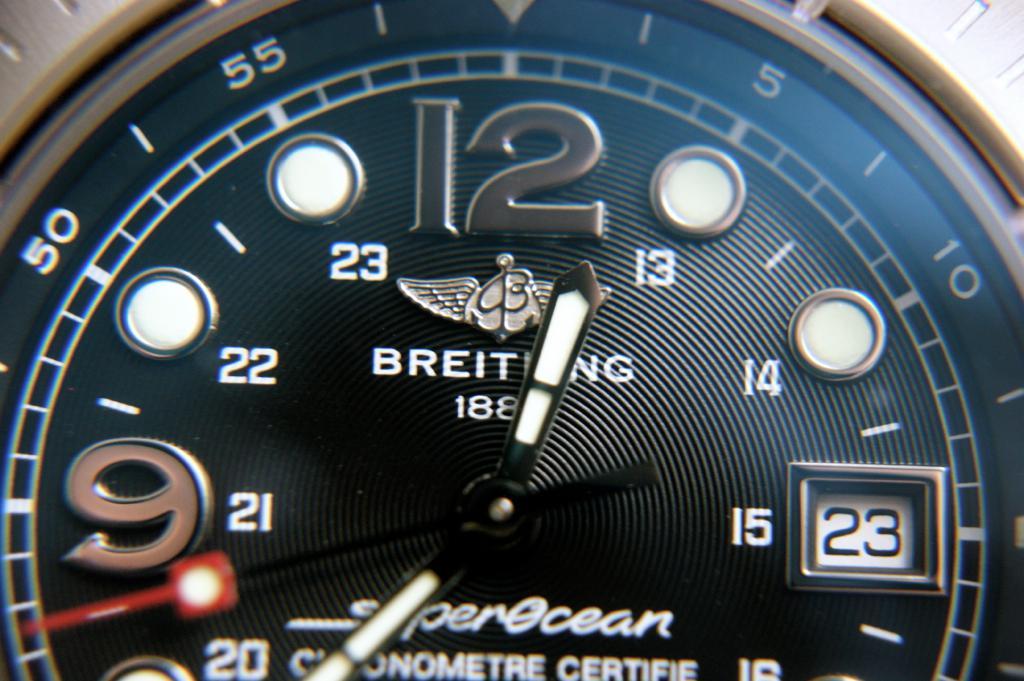What number is the date box?
Ensure brevity in your answer.  23. What is the number inside the box?
Your answer should be compact. 23. 